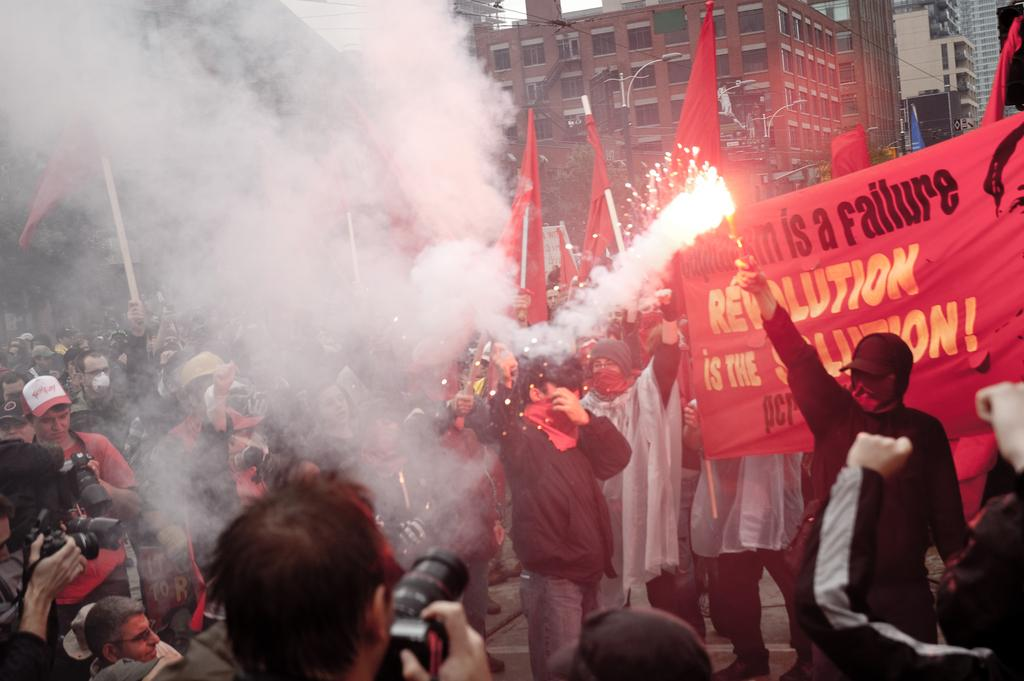<image>
Describe the image concisely. People protesting on a street holding a sign saying Revolution. 